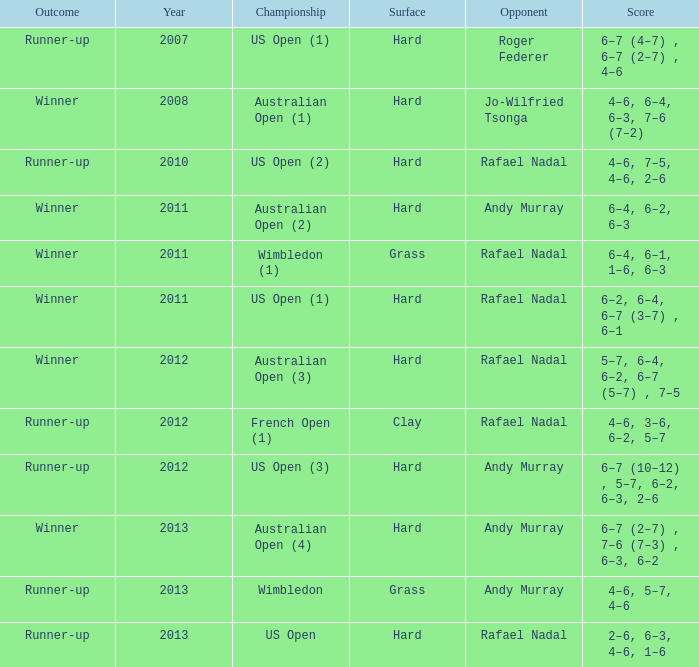What is the result of the game featuring roger federer as the adversary? Runner-up. 